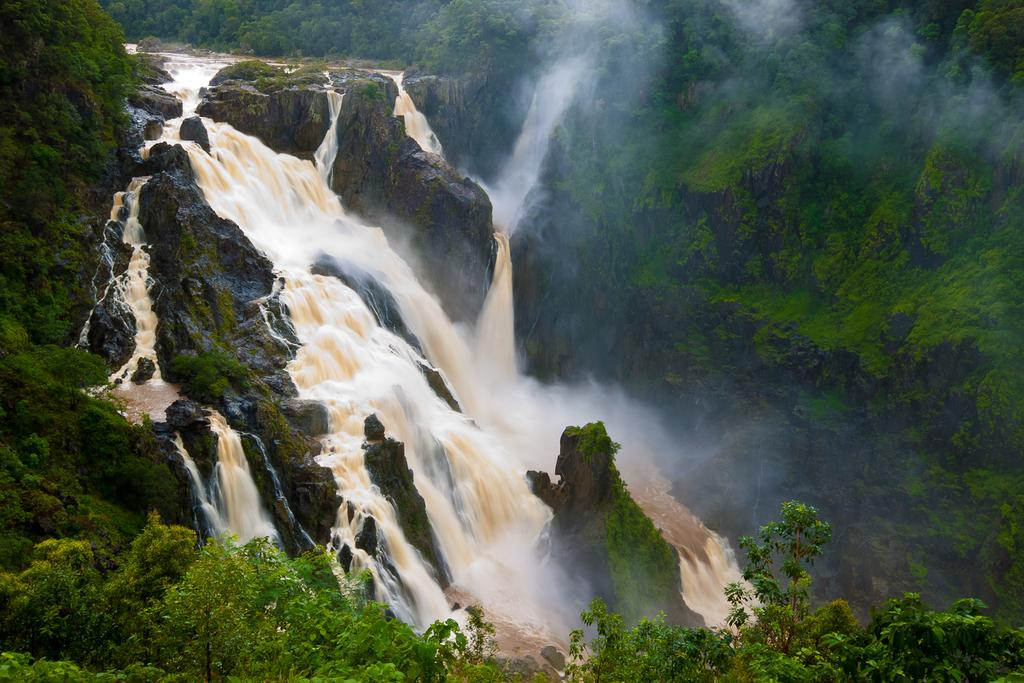What natural feature is the main subject of the image? There is a waterfall in the image. What type of objects can be seen near the waterfall? There are stones in the image. What type of vegetation is present on the left side of the image? There are trees on the left side of the image. What type of vegetation is present on the right side of the image? There are trees on the right side of the image. Can you tell me where the humor is located in the image? There is no humor present in the image; it is a natural scene featuring a waterfall, stones, and trees. What type of animal can be seen grazing near the waterfall in the image? There are no animals, including sheep, present in the image. 